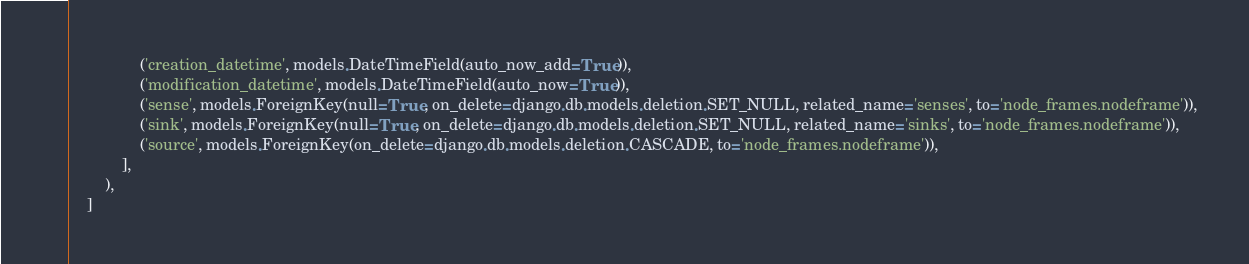Convert code to text. <code><loc_0><loc_0><loc_500><loc_500><_Python_>                ('creation_datetime', models.DateTimeField(auto_now_add=True)),
                ('modification_datetime', models.DateTimeField(auto_now=True)),
                ('sense', models.ForeignKey(null=True, on_delete=django.db.models.deletion.SET_NULL, related_name='senses', to='node_frames.nodeframe')),
                ('sink', models.ForeignKey(null=True, on_delete=django.db.models.deletion.SET_NULL, related_name='sinks', to='node_frames.nodeframe')),
                ('source', models.ForeignKey(on_delete=django.db.models.deletion.CASCADE, to='node_frames.nodeframe')),
            ],
        ),
    ]
</code> 